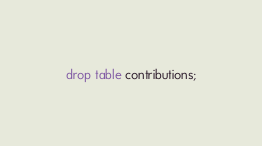<code> <loc_0><loc_0><loc_500><loc_500><_SQL_>drop table contributions;</code> 